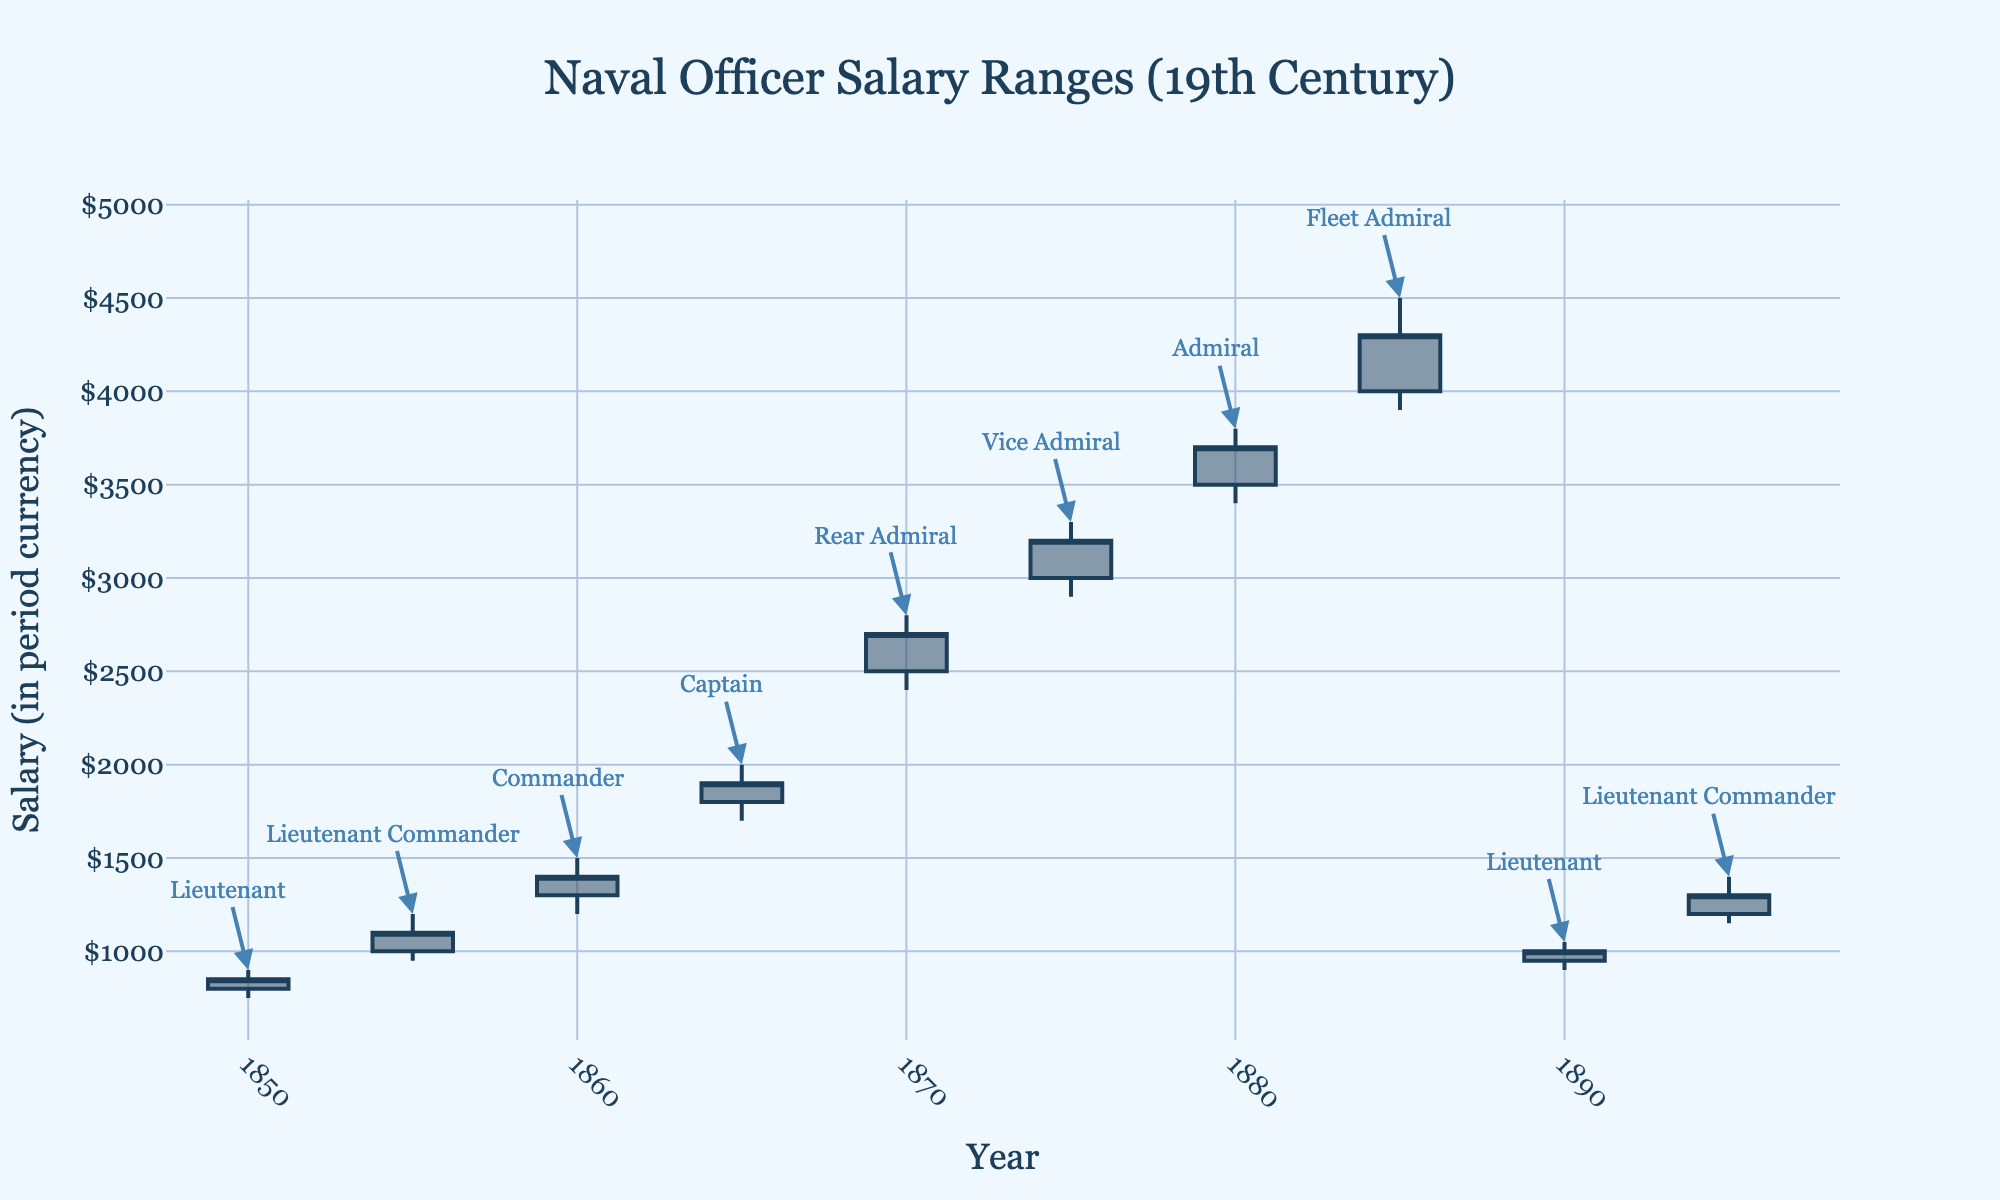Which year shows the highest salary range for a Fleet Admiral? The data point for Fleet Admiral shows a salary range of opening at $4000, high at $4500, low at $3900, and closing at $4300 in the year 1885, which is the highest among the ranks listed.
Answer: 1885 Which rank had the lowest opening salary in the data? The opening salary for a Lieutenant in 1850 is $800, which is the lowest opening salary among all ranks in the presented data.
Answer: Lieutenant in 1850 What was the closing salary for a Vice Admiral in 1875? Refer to the Vice Admiral data for 1875. The close salary is indicated as $3200.
Answer: $3200 Compare the high salary of a Commander in 1860 and a Captain in 1865. Which was higher? The high salary for a Commander in 1860 is $1500, while the high salary for a Captain in 1865 is $2000. Hence, the Captain in 1865 had a higher salary.
Answer: Captain in 1865 What is the difference between the high and low salary for a Rear Admiral in 1870? For a Rear Admiral in 1870, the high salary is $2800 and the low salary is $2400. The difference is calculated as $2800 - $2400 = $400.
Answer: $400 Which year shows a noticeable change in the salary range for a Lieutenant Commander? The salary range for a Lieutenant Commander in 1855 is $1000-$1200, and in 1895 it is $1200-$1400. The change is more significant in 1895 due to an overall increase in salaries from the previous years.
Answer: 1895 What was the highest salary recorded in the 19th century for any rank? The highest salary across all ranks and years is $4500 for a Fleet Admiral in 1885.
Answer: $4500 How does the close salary of a Commander in 1860 compare to the close salary of an Admiral in 1880? The close salary for a Commander in 1860 is $1400, while for an Admiral in 1880 it is $3700, indicating the Admiral's close salary is significantly higher.
Answer: Admiral in 1880 What is the average opening salary for the ranks listed in 1850 and 1890? The opening salary for a Lieutenant in 1850 is $800 and in 1890 is $950. The average is calculated as ($800 + $950) / 2 = $875.
Answer: $875 What was the overall trend in naval officer salaries from 1850 to 1895? There is a clear upward trend in naval officer salaries from 1850 to 1895, moving from a low of $800 in 1850 for a Lieutenant to as high as $4500 in 1885 for a Fleet Admiral, indicating an overall increase in salaries with time and rank.
Answer: Upward trend 